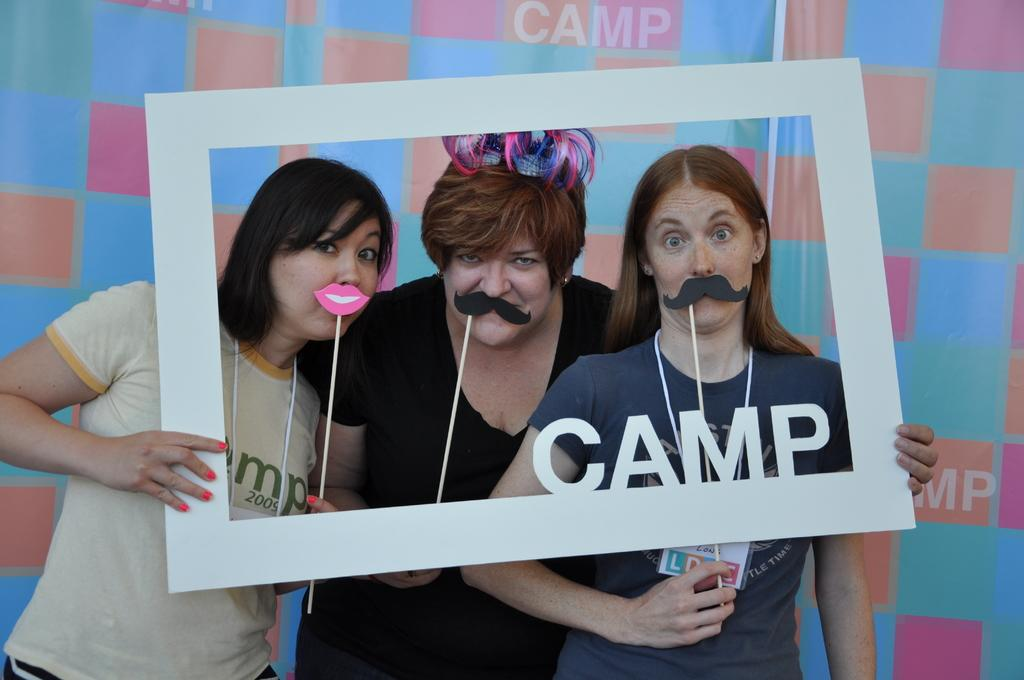How many people are in the image? There are three persons in the image. What are the persons doing in the image? The persons are standing. What are the persons holding in the image? The persons are holding a white-colored frame. What can be seen in the background of the image? There is a colorful banner in the background of the image. What type of agreement is being signed by the son in the image? There is no son present in the image, nor is there any indication of a signing event. 